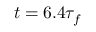Convert formula to latex. <formula><loc_0><loc_0><loc_500><loc_500>t = 6 . 4 \tau _ { f }</formula> 